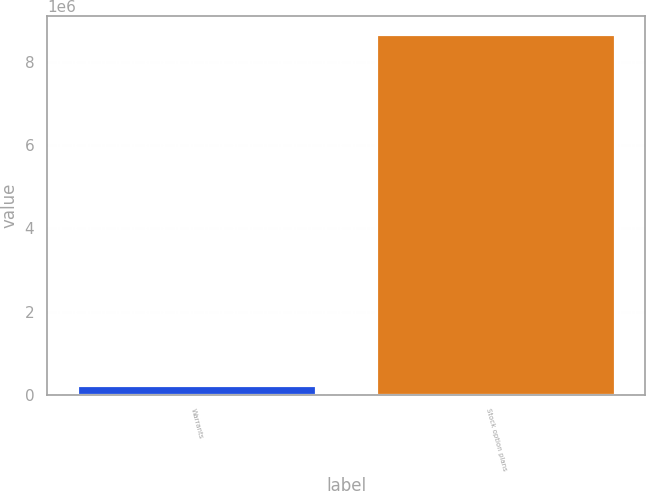Convert chart to OTSL. <chart><loc_0><loc_0><loc_500><loc_500><bar_chart><fcel>Warrants<fcel>Stock option plans<nl><fcel>238703<fcel>8.68425e+06<nl></chart> 